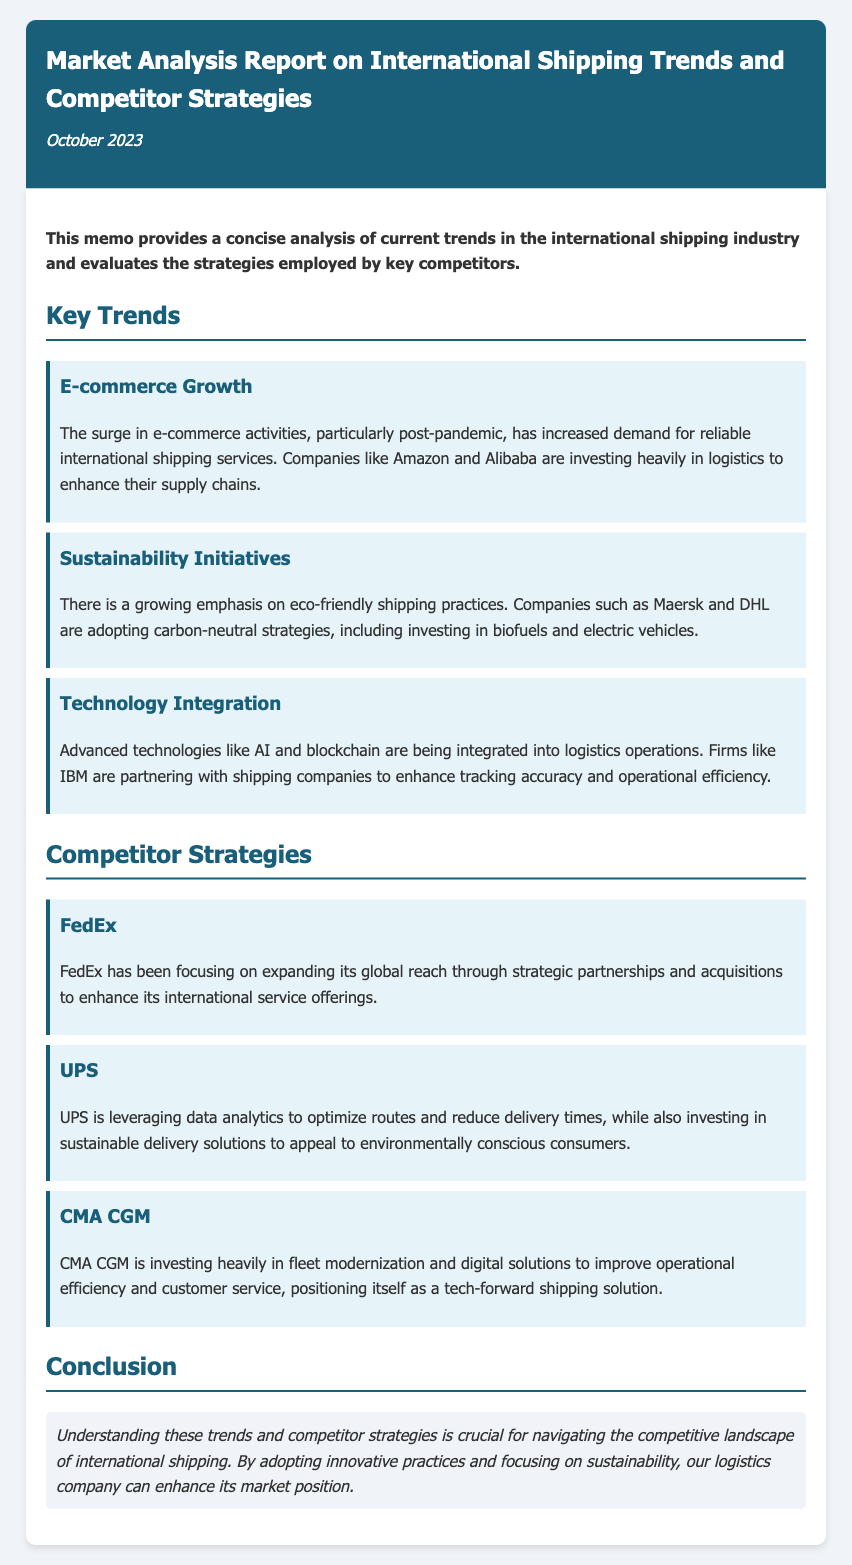What is the title of the memo? The title is explicitly stated at the top of the memo.
Answer: Market Analysis Report on International Shipping Trends and Competitor Strategies What date is listed on the memo? The date is provided below the title in the header section.
Answer: October 2023 Which company is mentioned as focusing on e-commerce growth? This information is found in the key trends section discussing the growth of e-commerce.
Answer: Amazon What sustainability initiative is mentioned in connection with Maersk? The strategy discussed relates to environmentally friendly shipping practices.
Answer: Carbon-neutral strategies Which company is known for investing in fleet modernization? This detail is found in the strategies employed by the competitors.
Answer: CMA CGM How is UPS optimizing its routes? This information is provided in the competitor strategies section detailing UPS's approach.
Answer: Data analytics What is a key technology mentioned that is being integrated into logistics operations? The technology referred to relates to advancements enhancing shipping practices.
Answer: AI What type of partnerships is FedEx focusing on? This detail regarding FedEx's strategy can be found under its individual strategy description.
Answer: Strategic partnerships What is emphasized as important for enhancing our market position? This conclusion is made based on the analysis provided in the memo.
Answer: Innovative practices and sustainability 